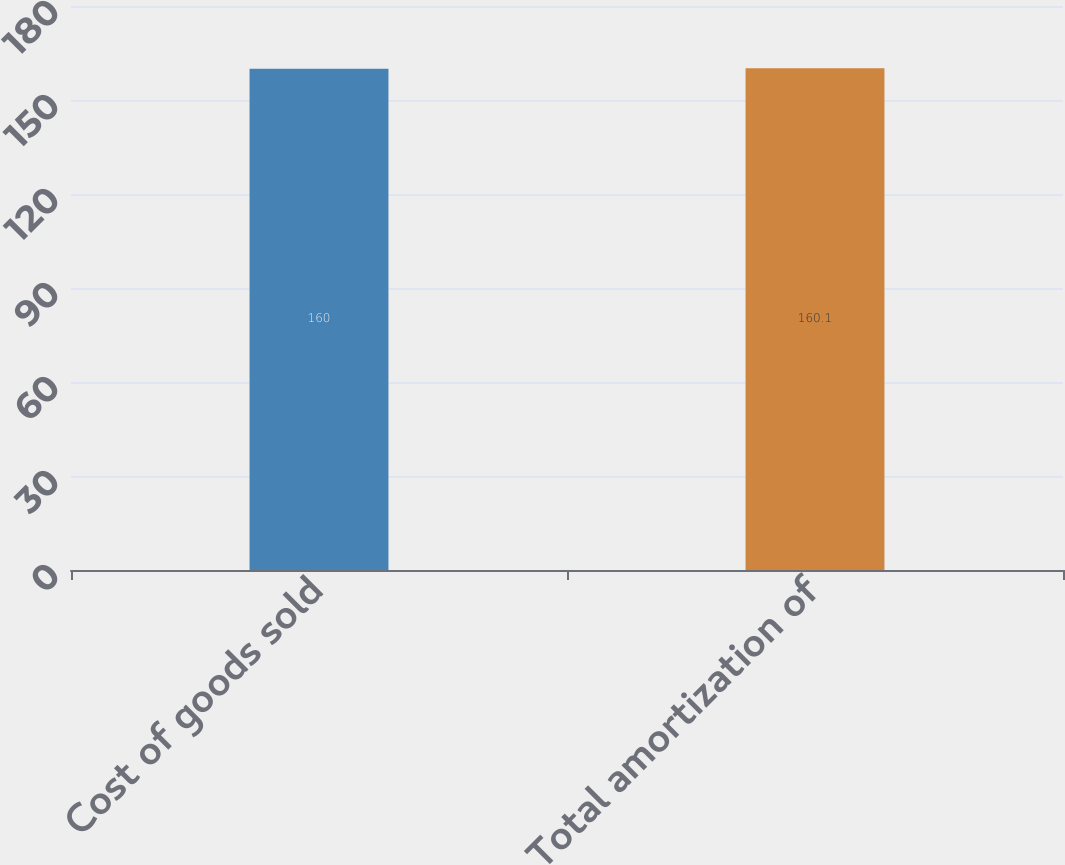<chart> <loc_0><loc_0><loc_500><loc_500><bar_chart><fcel>Cost of goods sold<fcel>Total amortization of<nl><fcel>160<fcel>160.1<nl></chart> 